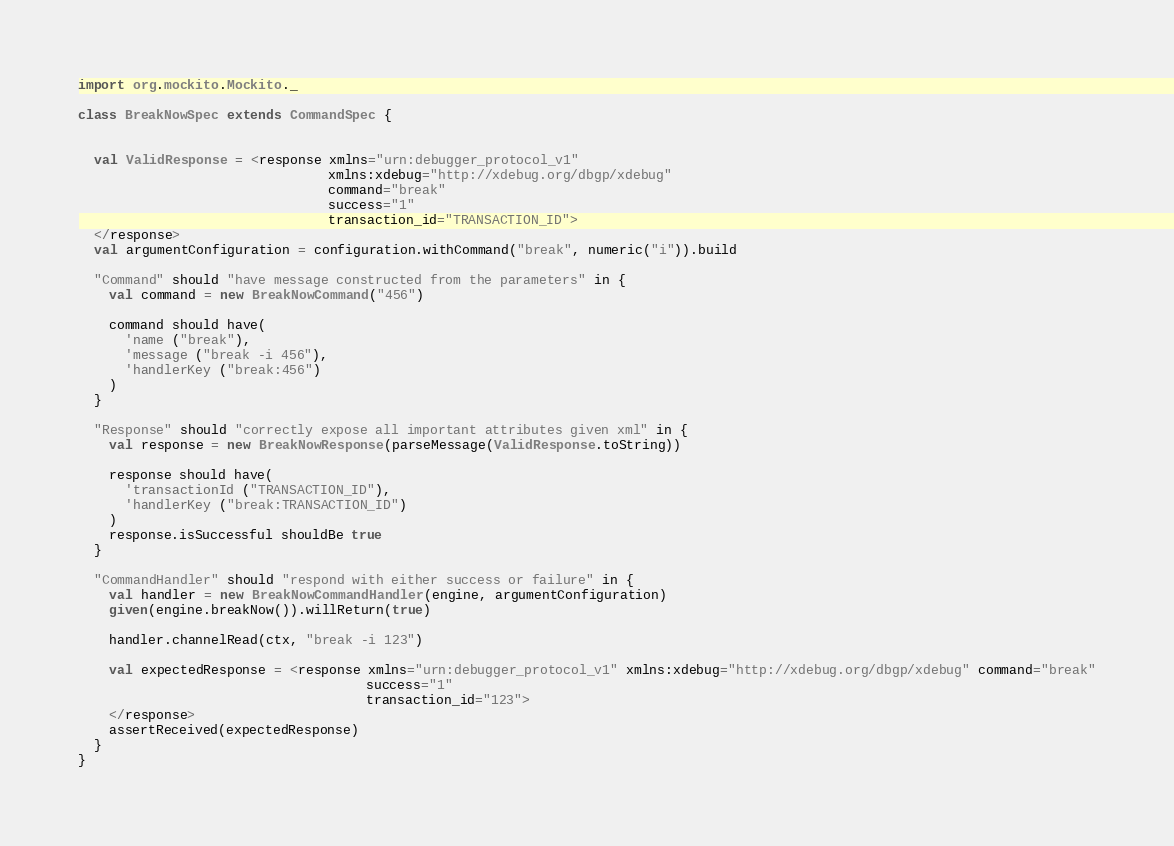<code> <loc_0><loc_0><loc_500><loc_500><_Scala_>import org.mockito.Mockito._

class BreakNowSpec extends CommandSpec {


  val ValidResponse = <response xmlns="urn:debugger_protocol_v1"
                                xmlns:xdebug="http://xdebug.org/dbgp/xdebug"
                                command="break"
                                success="1"
                                transaction_id="TRANSACTION_ID">
  </response>
  val argumentConfiguration = configuration.withCommand("break", numeric("i")).build

  "Command" should "have message constructed from the parameters" in {
    val command = new BreakNowCommand("456")

    command should have(
      'name ("break"),
      'message ("break -i 456"),
      'handlerKey ("break:456")
    )
  }

  "Response" should "correctly expose all important attributes given xml" in {
    val response = new BreakNowResponse(parseMessage(ValidResponse.toString))

    response should have(
      'transactionId ("TRANSACTION_ID"),
      'handlerKey ("break:TRANSACTION_ID")
    )
    response.isSuccessful shouldBe true
  }

  "CommandHandler" should "respond with either success or failure" in {
    val handler = new BreakNowCommandHandler(engine, argumentConfiguration)
    given(engine.breakNow()).willReturn(true)

    handler.channelRead(ctx, "break -i 123")

    val expectedResponse = <response xmlns="urn:debugger_protocol_v1" xmlns:xdebug="http://xdebug.org/dbgp/xdebug" command="break"
                                     success="1"
                                     transaction_id="123">
    </response>
    assertReceived(expectedResponse)
  }
}
</code> 